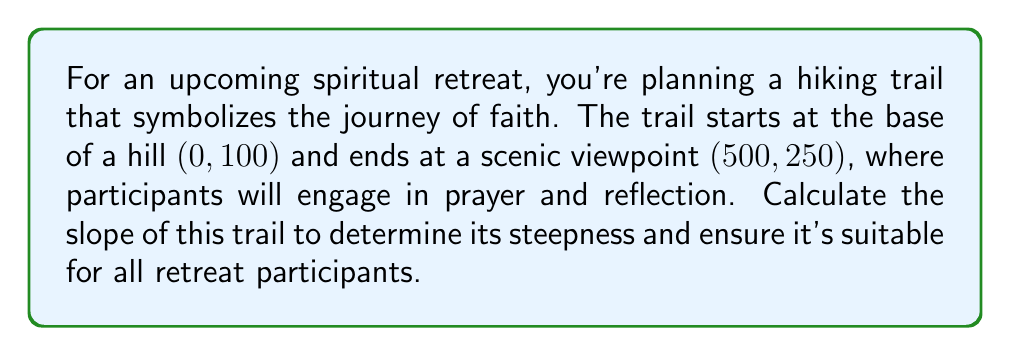Can you solve this math problem? To find the slope of the hiking trail, we'll use the slope formula:

$$ \text{slope} = m = \frac{y_2 - y_1}{x_2 - x_1} $$

Where $(x_1, y_1)$ is the starting point and $(x_2, y_2)$ is the ending point.

Given:
- Starting point: $(0, 100)$
- Ending point: $(500, 250)$

Let's plug these values into the slope formula:

$$ m = \frac{250 - 100}{500 - 0} $$

Simplifying:

$$ m = \frac{150}{500} $$

To reduce this fraction, we can divide both the numerator and denominator by their greatest common divisor (GCD). The GCD of 150 and 500 is 50.

$$ m = \frac{150 \div 50}{500 \div 50} = \frac{3}{10} = 0.3 $$

The slope can be interpreted as the rise over the run. In this case, for every 10 horizontal units, the trail rises 3 vertical units.

To convert this to a percentage grade, which is often used to describe the steepness of roads or trails, we multiply by 100:

$$ \text{Percentage grade} = 0.3 \times 100 = 30\% $$

This means the trail has a 30% grade, which is considered moderately steep but still manageable for most hikers.
Answer: The slope of the hiking trail is $\frac{3}{10}$ or 0.3, equivalent to a 30% grade. 